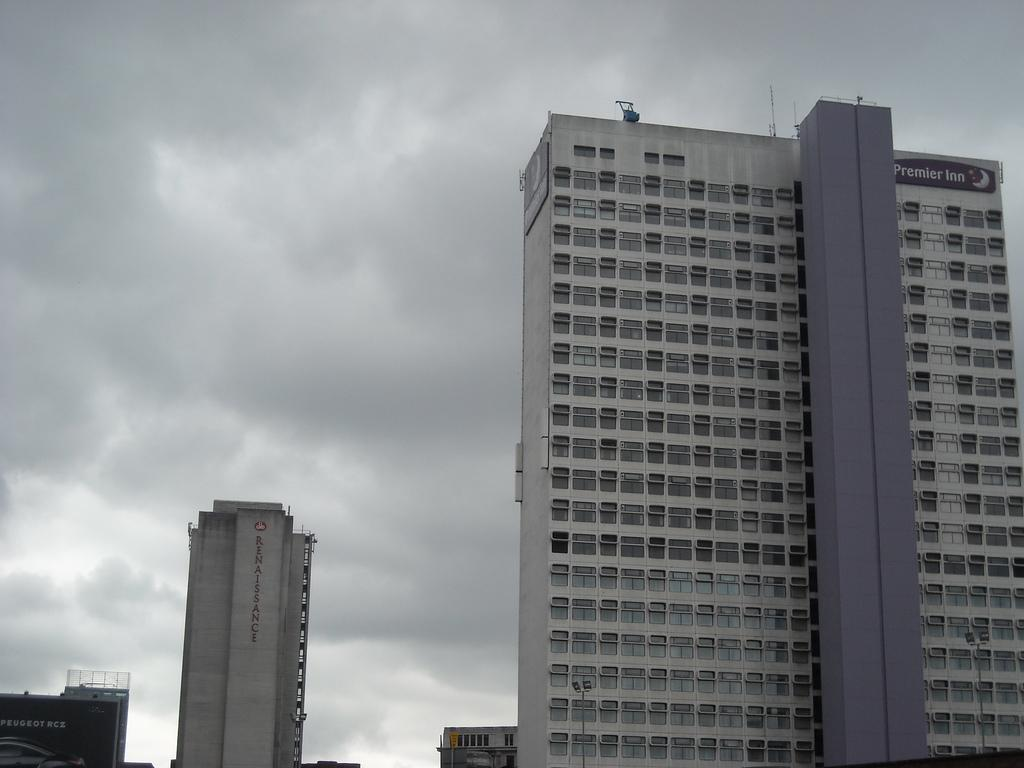What type of structures are present in the image? There are buildings in the image. What additional information can be found on the buildings? There are names on the buildings. What can be seen in the background of the image? The sky is visible in the background of the image. What is the source of fear in the image? There is no indication of fear in the image; it features buildings with names and a visible sky. Where is the bedroom located in the image? There is no bedroom present in the image. 